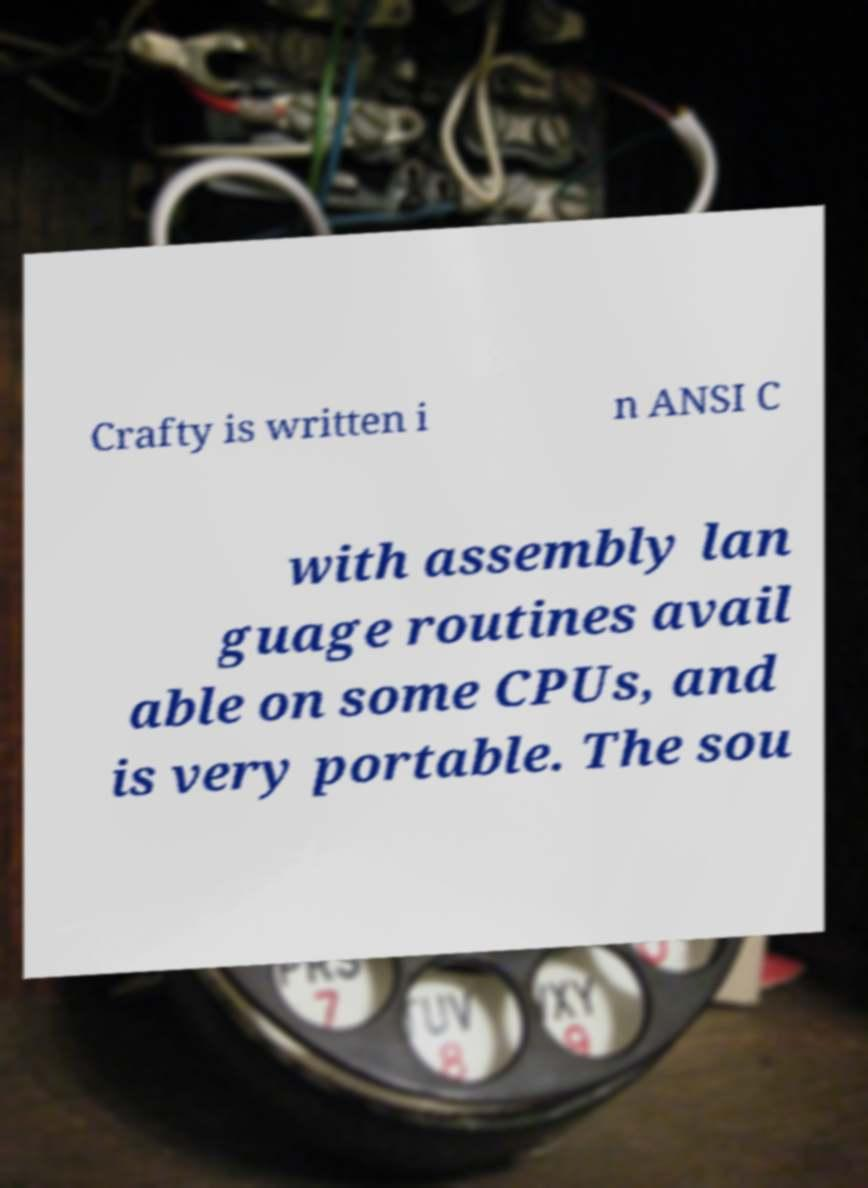Can you accurately transcribe the text from the provided image for me? Crafty is written i n ANSI C with assembly lan guage routines avail able on some CPUs, and is very portable. The sou 